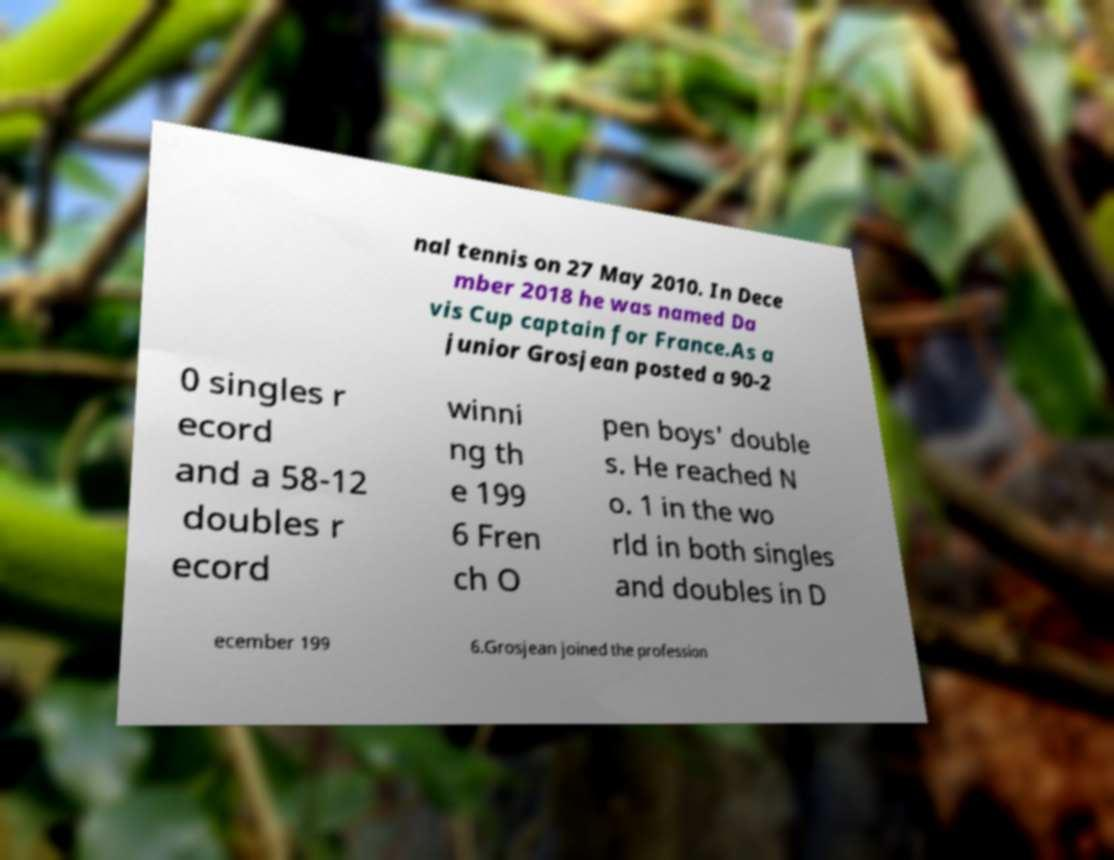There's text embedded in this image that I need extracted. Can you transcribe it verbatim? nal tennis on 27 May 2010. In Dece mber 2018 he was named Da vis Cup captain for France.As a junior Grosjean posted a 90-2 0 singles r ecord and a 58-12 doubles r ecord winni ng th e 199 6 Fren ch O pen boys' double s. He reached N o. 1 in the wo rld in both singles and doubles in D ecember 199 6.Grosjean joined the profession 